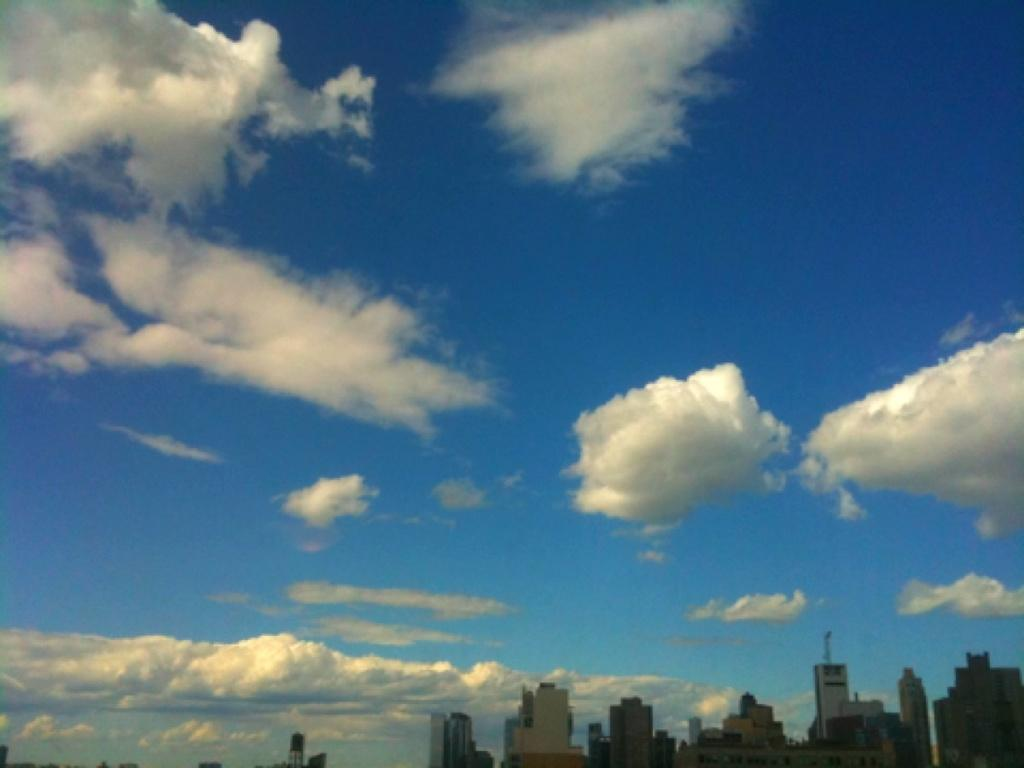What type of structures can be seen at the bottom of the image? There are buildings at the bottom of the image. What can be seen in the sky at the top of the image? There are clouds visible in the sky at the top of the image. What type of curtain can be seen hanging from the clouds in the image? There is no curtain present in the image; the clouds are in the sky. What type of toys are scattered around the buildings in the image? There are no toys present in the image; the image only features buildings and clouds. 